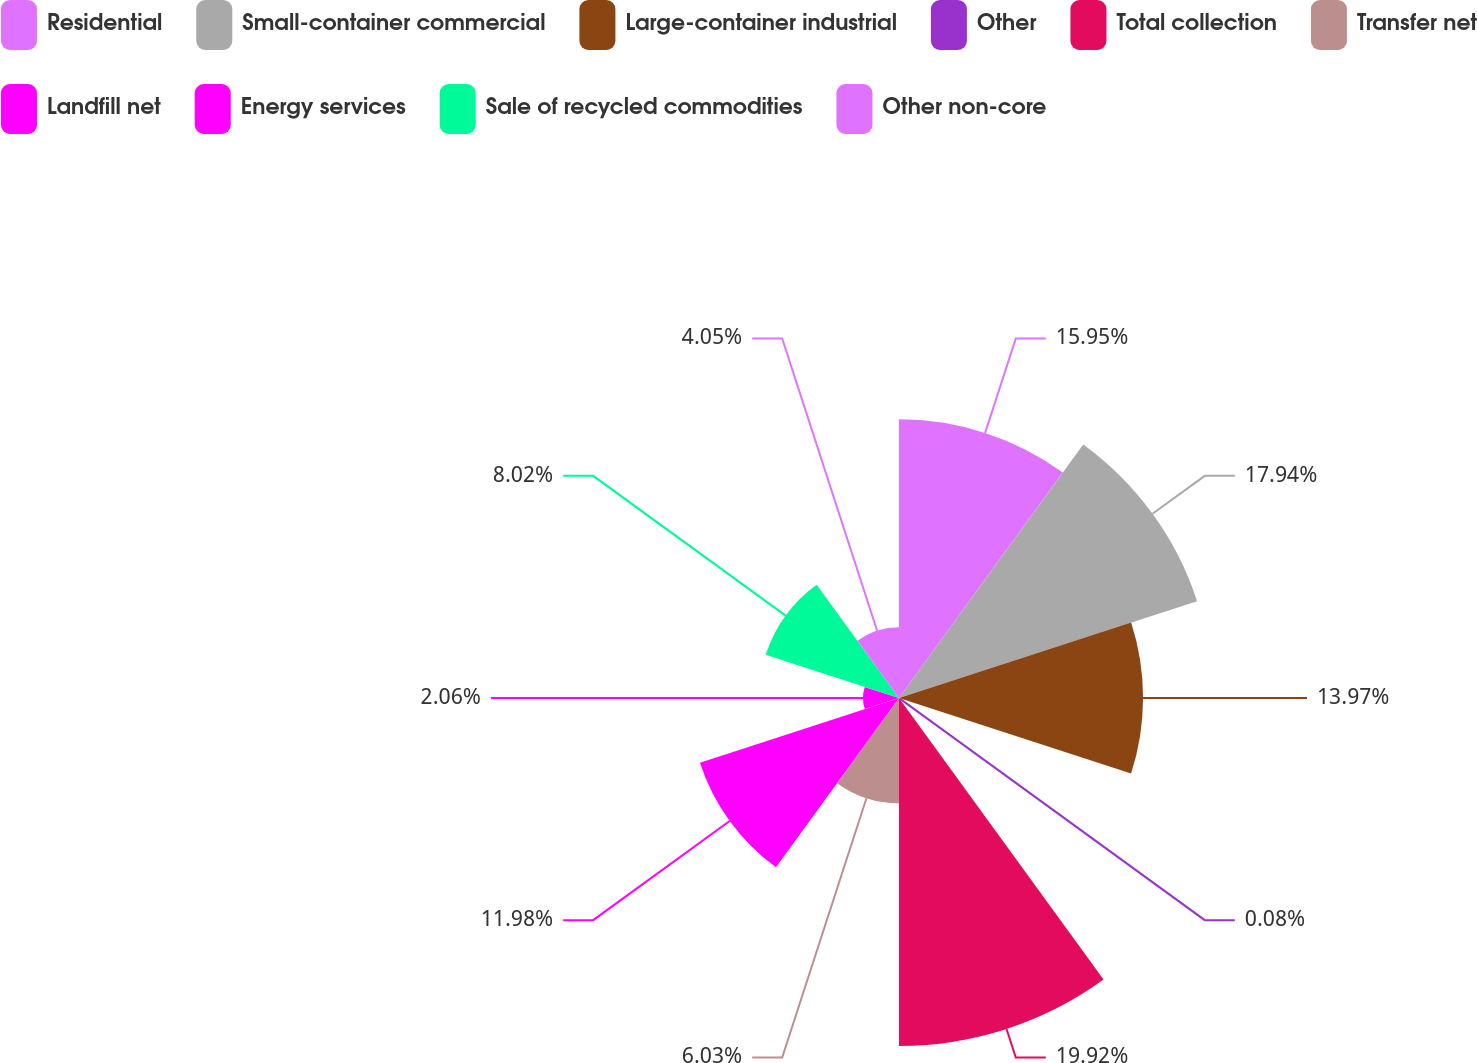<chart> <loc_0><loc_0><loc_500><loc_500><pie_chart><fcel>Residential<fcel>Small-container commercial<fcel>Large-container industrial<fcel>Other<fcel>Total collection<fcel>Transfer net<fcel>Landfill net<fcel>Energy services<fcel>Sale of recycled commodities<fcel>Other non-core<nl><fcel>15.95%<fcel>17.94%<fcel>13.97%<fcel>0.08%<fcel>19.92%<fcel>6.03%<fcel>11.98%<fcel>2.06%<fcel>8.02%<fcel>4.05%<nl></chart> 